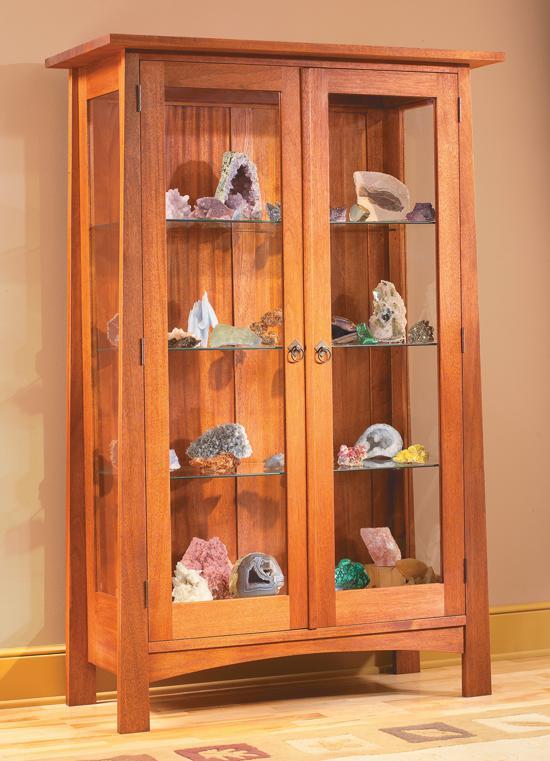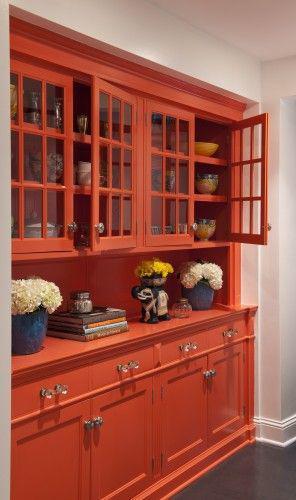The first image is the image on the left, the second image is the image on the right. Examine the images to the left and right. Is the description "There are exactly three drawers on the cabinet in the image on the right." accurate? Answer yes or no. No. 